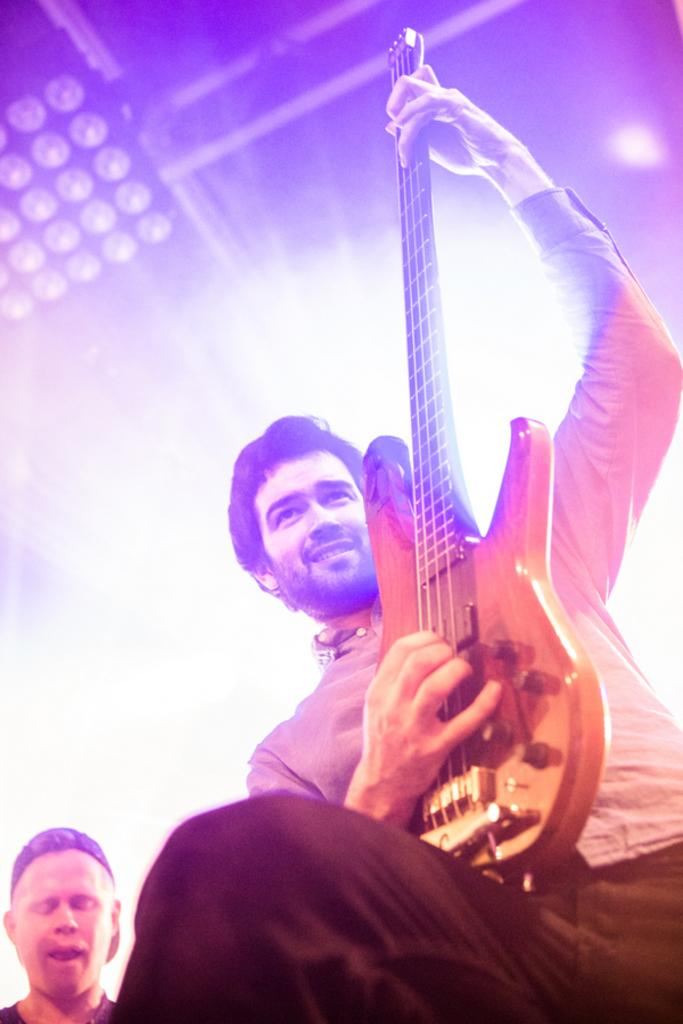What is the man in the image doing? There is a man playing a guitar in the image. Can you describe the other man in the image? There is a man standing in the image. What type of plantation can be seen in the background of the image? There is no plantation present in the image; it features two men, one playing a guitar and the other standing. 